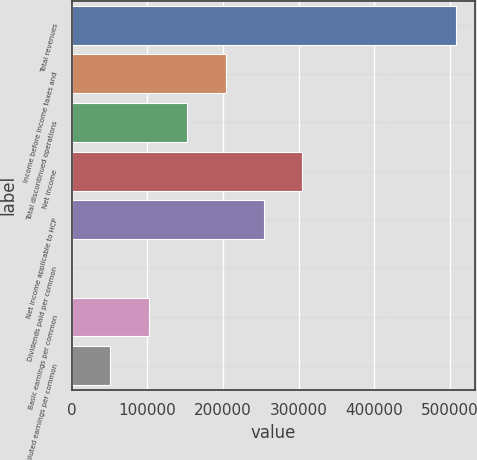Convert chart. <chart><loc_0><loc_0><loc_500><loc_500><bar_chart><fcel>Total revenues<fcel>Income before income taxes and<fcel>Total discontinued operations<fcel>Net income<fcel>Net income applicable to HCP<fcel>Dividends paid per common<fcel>Basic earnings per common<fcel>Diluted earnings per common<nl><fcel>508487<fcel>203395<fcel>152546<fcel>305092<fcel>254244<fcel>0.5<fcel>101698<fcel>50849.2<nl></chart> 